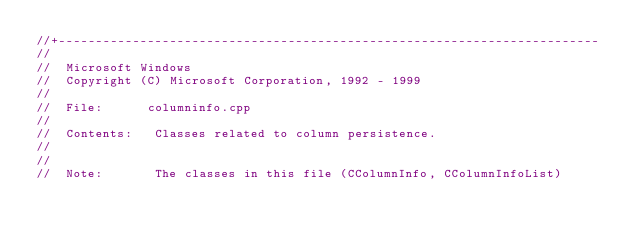Convert code to text. <code><loc_0><loc_0><loc_500><loc_500><_C++_>//+-------------------------------------------------------------------------
//
//  Microsoft Windows
//  Copyright (C) Microsoft Corporation, 1992 - 1999
//
//  File:      columninfo.cpp
//
//  Contents:   Classes related to column persistence.
//
//
//  Note:       The classes in this file (CColumnInfo, CColumnInfoList)</code> 